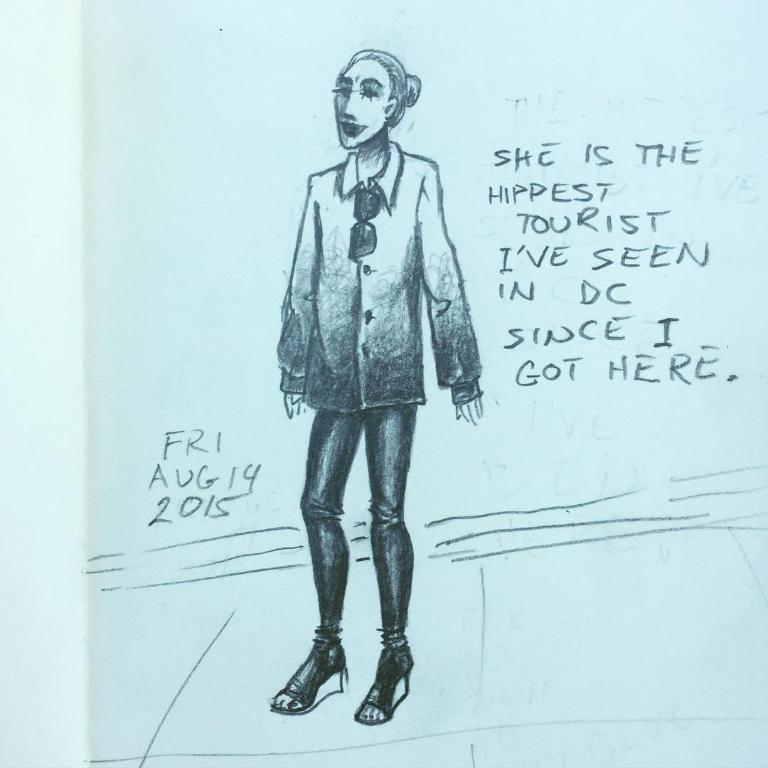What is depicted in the image? There is a drawing of a person in the image. What else can be found in the image besides the drawing? There is text in the image. Can you hear the train passing by in the image? There is no train or sound mentioned in the image; it only contains a drawing of a person and text. Is there a squirrel visible in the image? There is no squirrel present in the image. 